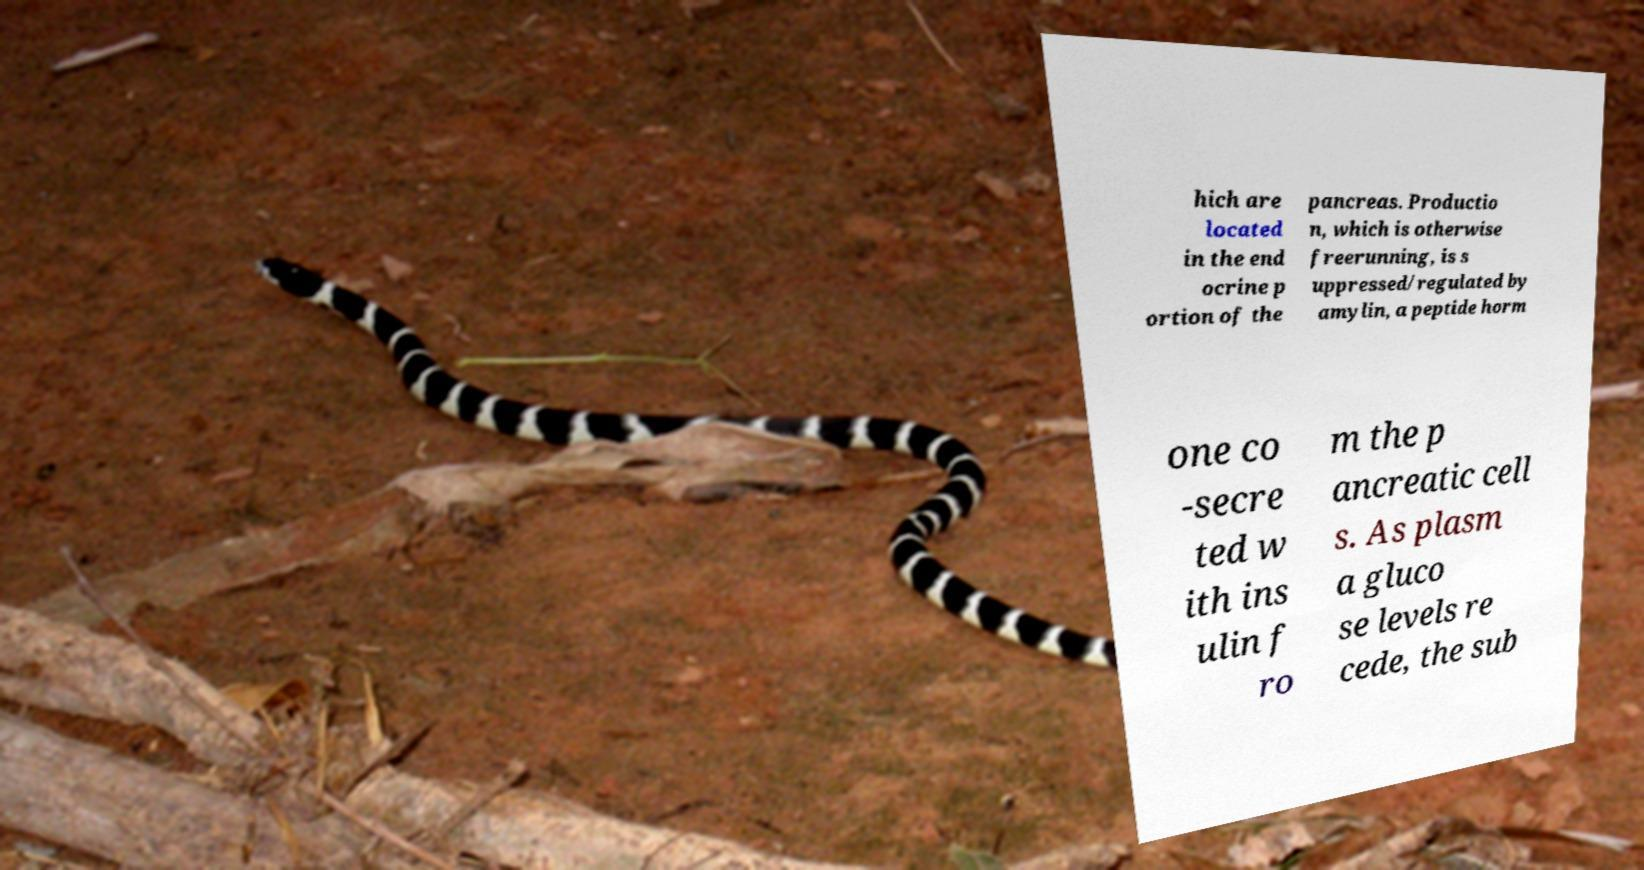Can you read and provide the text displayed in the image?This photo seems to have some interesting text. Can you extract and type it out for me? hich are located in the end ocrine p ortion of the pancreas. Productio n, which is otherwise freerunning, is s uppressed/regulated by amylin, a peptide horm one co -secre ted w ith ins ulin f ro m the p ancreatic cell s. As plasm a gluco se levels re cede, the sub 